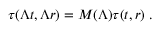<formula> <loc_0><loc_0><loc_500><loc_500>\tau ( \Lambda t , \Lambda r ) = M ( \Lambda ) \tau ( t , r ) \, .</formula> 